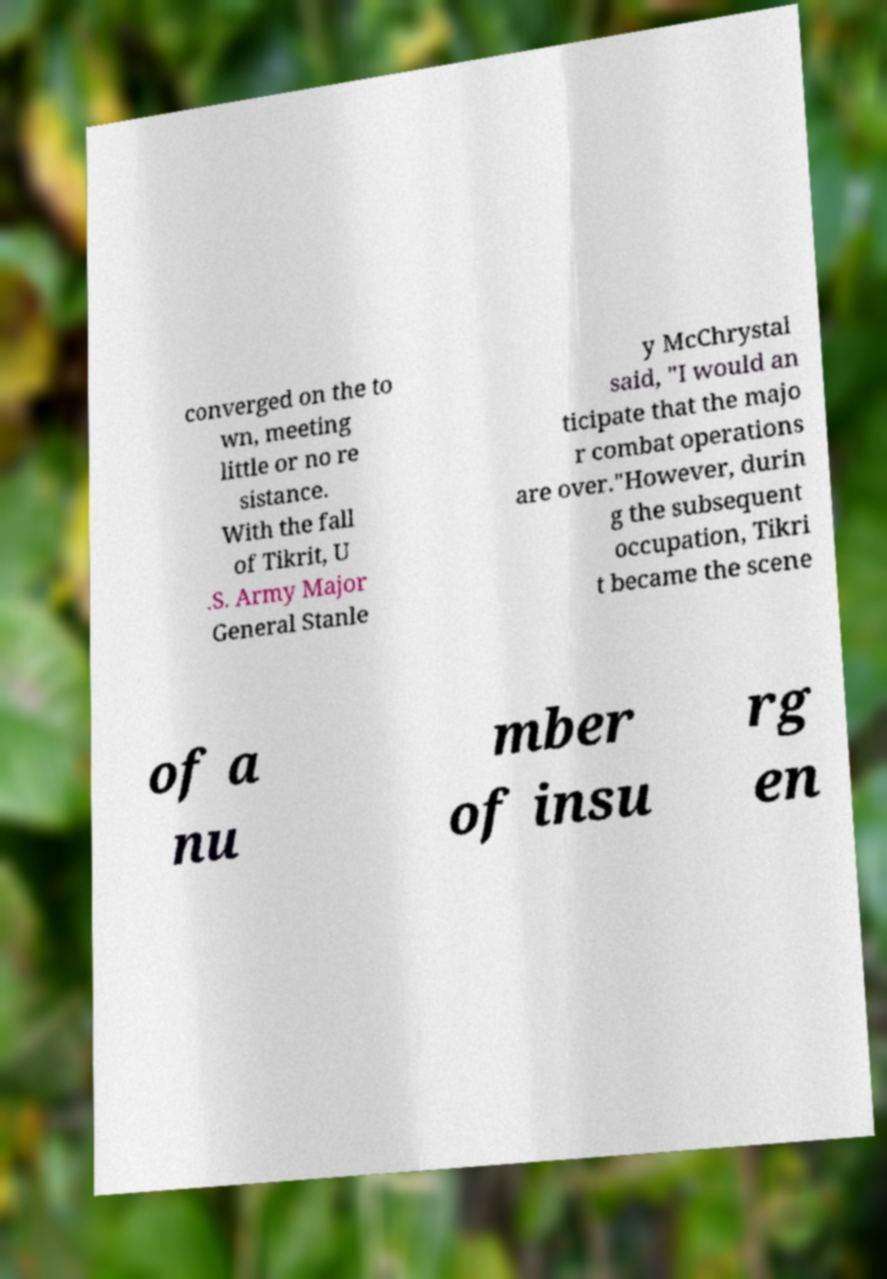I need the written content from this picture converted into text. Can you do that? converged on the to wn, meeting little or no re sistance. With the fall of Tikrit, U .S. Army Major General Stanle y McChrystal said, "I would an ticipate that the majo r combat operations are over."However, durin g the subsequent occupation, Tikri t became the scene of a nu mber of insu rg en 